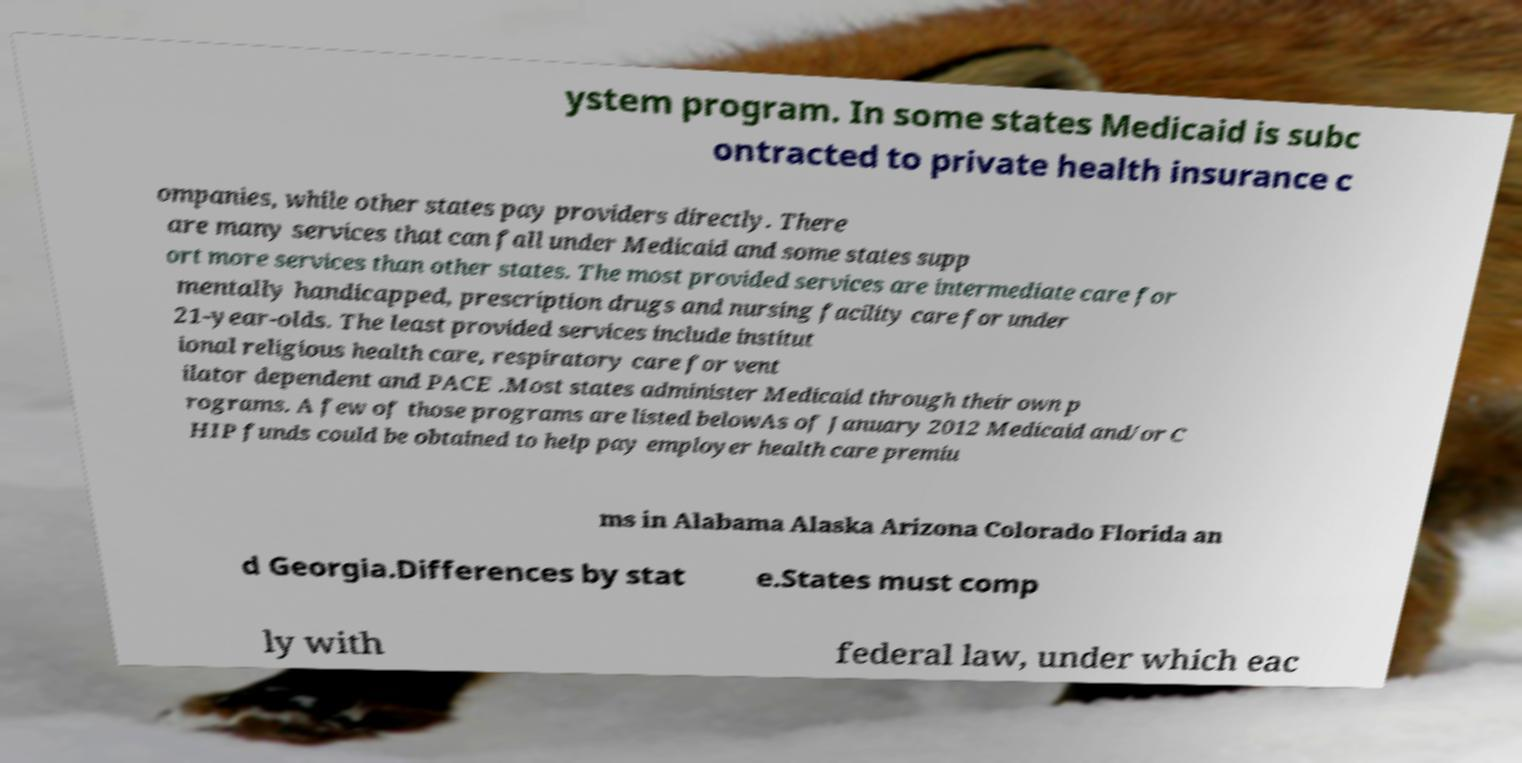What messages or text are displayed in this image? I need them in a readable, typed format. ystem program. In some states Medicaid is subc ontracted to private health insurance c ompanies, while other states pay providers directly. There are many services that can fall under Medicaid and some states supp ort more services than other states. The most provided services are intermediate care for mentally handicapped, prescription drugs and nursing facility care for under 21-year-olds. The least provided services include institut ional religious health care, respiratory care for vent ilator dependent and PACE .Most states administer Medicaid through their own p rograms. A few of those programs are listed belowAs of January 2012 Medicaid and/or C HIP funds could be obtained to help pay employer health care premiu ms in Alabama Alaska Arizona Colorado Florida an d Georgia.Differences by stat e.States must comp ly with federal law, under which eac 